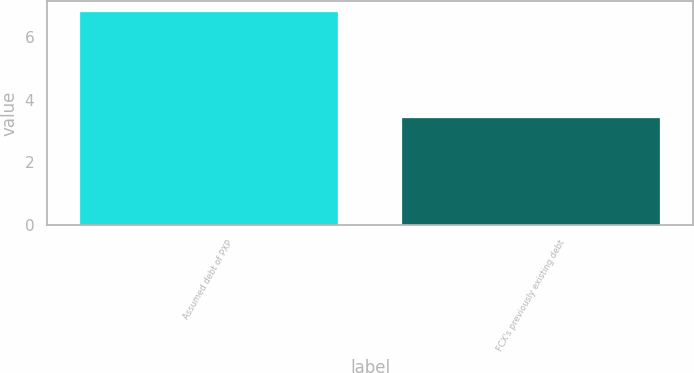Convert chart to OTSL. <chart><loc_0><loc_0><loc_500><loc_500><bar_chart><fcel>Assumed debt of PXP<fcel>FCX's previously existing debt<nl><fcel>6.8<fcel>3.4<nl></chart> 